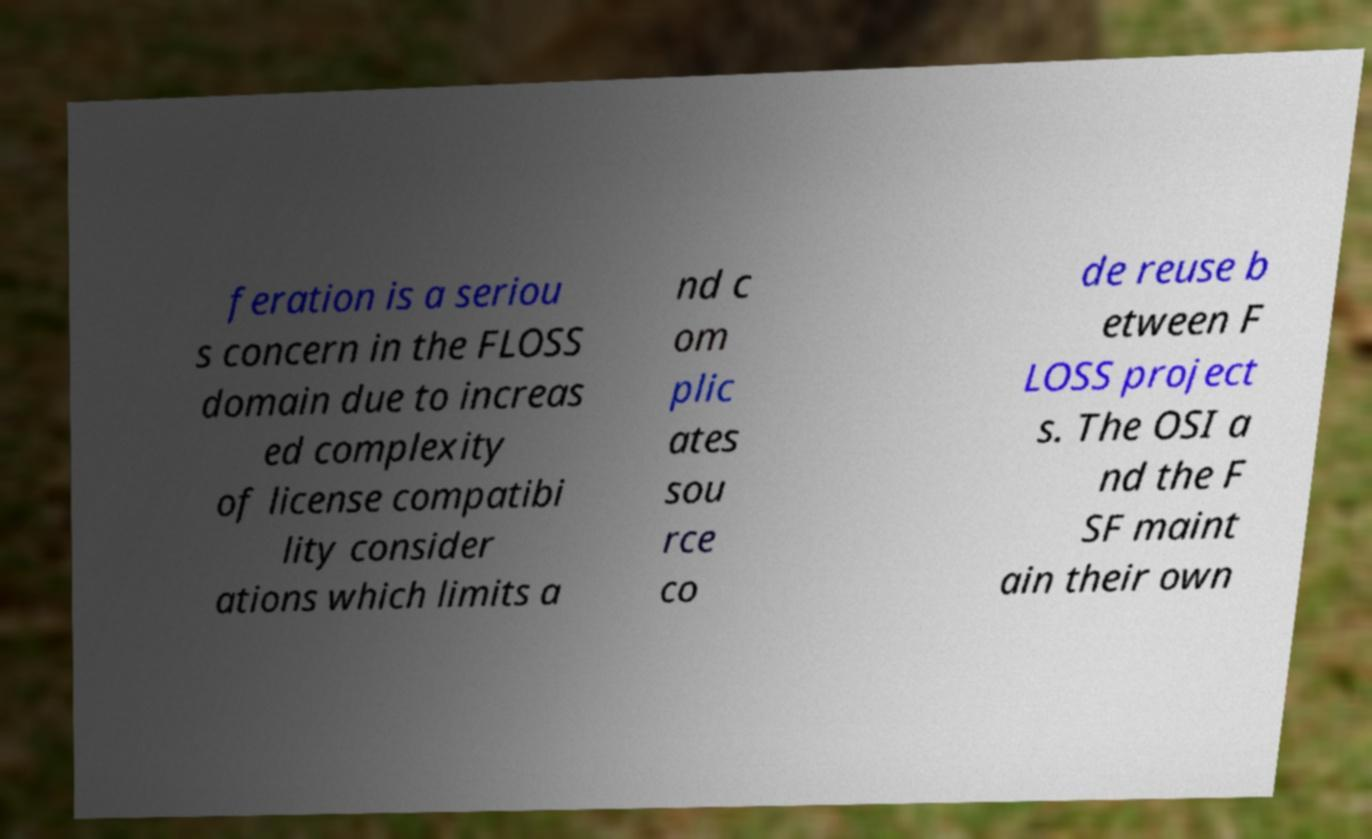There's text embedded in this image that I need extracted. Can you transcribe it verbatim? feration is a seriou s concern in the FLOSS domain due to increas ed complexity of license compatibi lity consider ations which limits a nd c om plic ates sou rce co de reuse b etween F LOSS project s. The OSI a nd the F SF maint ain their own 